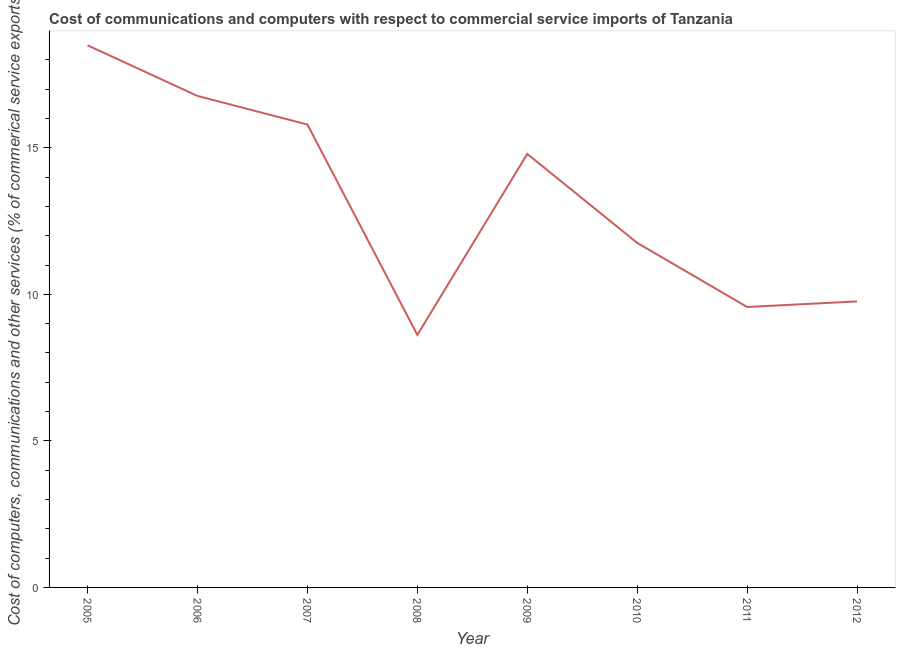What is the cost of communications in 2012?
Your answer should be very brief. 9.76. Across all years, what is the maximum  computer and other services?
Your answer should be compact. 18.5. Across all years, what is the minimum cost of communications?
Your answer should be compact. 8.62. What is the sum of the cost of communications?
Make the answer very short. 105.54. What is the difference between the  computer and other services in 2006 and 2009?
Offer a very short reply. 1.98. What is the average cost of communications per year?
Offer a very short reply. 13.19. What is the median  computer and other services?
Your answer should be very brief. 13.27. What is the ratio of the cost of communications in 2007 to that in 2011?
Offer a very short reply. 1.65. Is the difference between the cost of communications in 2007 and 2008 greater than the difference between any two years?
Your answer should be very brief. No. What is the difference between the highest and the second highest cost of communications?
Your answer should be compact. 1.73. What is the difference between the highest and the lowest cost of communications?
Provide a short and direct response. 9.88. Does the  computer and other services monotonically increase over the years?
Offer a terse response. No. How many lines are there?
Provide a succinct answer. 1. How many years are there in the graph?
Offer a terse response. 8. Are the values on the major ticks of Y-axis written in scientific E-notation?
Your answer should be compact. No. Does the graph contain any zero values?
Your answer should be very brief. No. What is the title of the graph?
Give a very brief answer. Cost of communications and computers with respect to commercial service imports of Tanzania. What is the label or title of the Y-axis?
Offer a very short reply. Cost of computers, communications and other services (% of commerical service exports). What is the Cost of computers, communications and other services (% of commerical service exports) of 2005?
Keep it short and to the point. 18.5. What is the Cost of computers, communications and other services (% of commerical service exports) in 2006?
Offer a terse response. 16.77. What is the Cost of computers, communications and other services (% of commerical service exports) in 2007?
Give a very brief answer. 15.79. What is the Cost of computers, communications and other services (% of commerical service exports) in 2008?
Your answer should be very brief. 8.62. What is the Cost of computers, communications and other services (% of commerical service exports) in 2009?
Your response must be concise. 14.79. What is the Cost of computers, communications and other services (% of commerical service exports) in 2010?
Your answer should be very brief. 11.76. What is the Cost of computers, communications and other services (% of commerical service exports) of 2011?
Keep it short and to the point. 9.57. What is the Cost of computers, communications and other services (% of commerical service exports) of 2012?
Give a very brief answer. 9.76. What is the difference between the Cost of computers, communications and other services (% of commerical service exports) in 2005 and 2006?
Make the answer very short. 1.73. What is the difference between the Cost of computers, communications and other services (% of commerical service exports) in 2005 and 2007?
Give a very brief answer. 2.7. What is the difference between the Cost of computers, communications and other services (% of commerical service exports) in 2005 and 2008?
Your response must be concise. 9.88. What is the difference between the Cost of computers, communications and other services (% of commerical service exports) in 2005 and 2009?
Your response must be concise. 3.71. What is the difference between the Cost of computers, communications and other services (% of commerical service exports) in 2005 and 2010?
Your response must be concise. 6.74. What is the difference between the Cost of computers, communications and other services (% of commerical service exports) in 2005 and 2011?
Make the answer very short. 8.93. What is the difference between the Cost of computers, communications and other services (% of commerical service exports) in 2005 and 2012?
Give a very brief answer. 8.74. What is the difference between the Cost of computers, communications and other services (% of commerical service exports) in 2006 and 2007?
Keep it short and to the point. 0.98. What is the difference between the Cost of computers, communications and other services (% of commerical service exports) in 2006 and 2008?
Give a very brief answer. 8.15. What is the difference between the Cost of computers, communications and other services (% of commerical service exports) in 2006 and 2009?
Give a very brief answer. 1.98. What is the difference between the Cost of computers, communications and other services (% of commerical service exports) in 2006 and 2010?
Give a very brief answer. 5.01. What is the difference between the Cost of computers, communications and other services (% of commerical service exports) in 2006 and 2011?
Ensure brevity in your answer.  7.2. What is the difference between the Cost of computers, communications and other services (% of commerical service exports) in 2006 and 2012?
Offer a very short reply. 7.01. What is the difference between the Cost of computers, communications and other services (% of commerical service exports) in 2007 and 2008?
Your response must be concise. 7.18. What is the difference between the Cost of computers, communications and other services (% of commerical service exports) in 2007 and 2009?
Give a very brief answer. 1. What is the difference between the Cost of computers, communications and other services (% of commerical service exports) in 2007 and 2010?
Ensure brevity in your answer.  4.04. What is the difference between the Cost of computers, communications and other services (% of commerical service exports) in 2007 and 2011?
Your answer should be very brief. 6.22. What is the difference between the Cost of computers, communications and other services (% of commerical service exports) in 2007 and 2012?
Provide a succinct answer. 6.03. What is the difference between the Cost of computers, communications and other services (% of commerical service exports) in 2008 and 2009?
Your answer should be very brief. -6.17. What is the difference between the Cost of computers, communications and other services (% of commerical service exports) in 2008 and 2010?
Offer a very short reply. -3.14. What is the difference between the Cost of computers, communications and other services (% of commerical service exports) in 2008 and 2011?
Offer a terse response. -0.95. What is the difference between the Cost of computers, communications and other services (% of commerical service exports) in 2008 and 2012?
Offer a terse response. -1.14. What is the difference between the Cost of computers, communications and other services (% of commerical service exports) in 2009 and 2010?
Provide a short and direct response. 3.04. What is the difference between the Cost of computers, communications and other services (% of commerical service exports) in 2009 and 2011?
Your response must be concise. 5.22. What is the difference between the Cost of computers, communications and other services (% of commerical service exports) in 2009 and 2012?
Ensure brevity in your answer.  5.03. What is the difference between the Cost of computers, communications and other services (% of commerical service exports) in 2010 and 2011?
Your answer should be very brief. 2.19. What is the difference between the Cost of computers, communications and other services (% of commerical service exports) in 2010 and 2012?
Your answer should be compact. 2. What is the difference between the Cost of computers, communications and other services (% of commerical service exports) in 2011 and 2012?
Your answer should be very brief. -0.19. What is the ratio of the Cost of computers, communications and other services (% of commerical service exports) in 2005 to that in 2006?
Ensure brevity in your answer.  1.1. What is the ratio of the Cost of computers, communications and other services (% of commerical service exports) in 2005 to that in 2007?
Offer a very short reply. 1.17. What is the ratio of the Cost of computers, communications and other services (% of commerical service exports) in 2005 to that in 2008?
Give a very brief answer. 2.15. What is the ratio of the Cost of computers, communications and other services (% of commerical service exports) in 2005 to that in 2009?
Provide a succinct answer. 1.25. What is the ratio of the Cost of computers, communications and other services (% of commerical service exports) in 2005 to that in 2010?
Your answer should be compact. 1.57. What is the ratio of the Cost of computers, communications and other services (% of commerical service exports) in 2005 to that in 2011?
Provide a short and direct response. 1.93. What is the ratio of the Cost of computers, communications and other services (% of commerical service exports) in 2005 to that in 2012?
Your answer should be compact. 1.9. What is the ratio of the Cost of computers, communications and other services (% of commerical service exports) in 2006 to that in 2007?
Offer a very short reply. 1.06. What is the ratio of the Cost of computers, communications and other services (% of commerical service exports) in 2006 to that in 2008?
Provide a short and direct response. 1.95. What is the ratio of the Cost of computers, communications and other services (% of commerical service exports) in 2006 to that in 2009?
Ensure brevity in your answer.  1.13. What is the ratio of the Cost of computers, communications and other services (% of commerical service exports) in 2006 to that in 2010?
Your answer should be compact. 1.43. What is the ratio of the Cost of computers, communications and other services (% of commerical service exports) in 2006 to that in 2011?
Offer a very short reply. 1.75. What is the ratio of the Cost of computers, communications and other services (% of commerical service exports) in 2006 to that in 2012?
Offer a terse response. 1.72. What is the ratio of the Cost of computers, communications and other services (% of commerical service exports) in 2007 to that in 2008?
Your answer should be compact. 1.83. What is the ratio of the Cost of computers, communications and other services (% of commerical service exports) in 2007 to that in 2009?
Your answer should be very brief. 1.07. What is the ratio of the Cost of computers, communications and other services (% of commerical service exports) in 2007 to that in 2010?
Offer a terse response. 1.34. What is the ratio of the Cost of computers, communications and other services (% of commerical service exports) in 2007 to that in 2011?
Make the answer very short. 1.65. What is the ratio of the Cost of computers, communications and other services (% of commerical service exports) in 2007 to that in 2012?
Provide a succinct answer. 1.62. What is the ratio of the Cost of computers, communications and other services (% of commerical service exports) in 2008 to that in 2009?
Keep it short and to the point. 0.58. What is the ratio of the Cost of computers, communications and other services (% of commerical service exports) in 2008 to that in 2010?
Your answer should be very brief. 0.73. What is the ratio of the Cost of computers, communications and other services (% of commerical service exports) in 2008 to that in 2011?
Make the answer very short. 0.9. What is the ratio of the Cost of computers, communications and other services (% of commerical service exports) in 2008 to that in 2012?
Your response must be concise. 0.88. What is the ratio of the Cost of computers, communications and other services (% of commerical service exports) in 2009 to that in 2010?
Offer a very short reply. 1.26. What is the ratio of the Cost of computers, communications and other services (% of commerical service exports) in 2009 to that in 2011?
Offer a terse response. 1.55. What is the ratio of the Cost of computers, communications and other services (% of commerical service exports) in 2009 to that in 2012?
Your response must be concise. 1.52. What is the ratio of the Cost of computers, communications and other services (% of commerical service exports) in 2010 to that in 2011?
Provide a short and direct response. 1.23. What is the ratio of the Cost of computers, communications and other services (% of commerical service exports) in 2010 to that in 2012?
Your response must be concise. 1.21. 